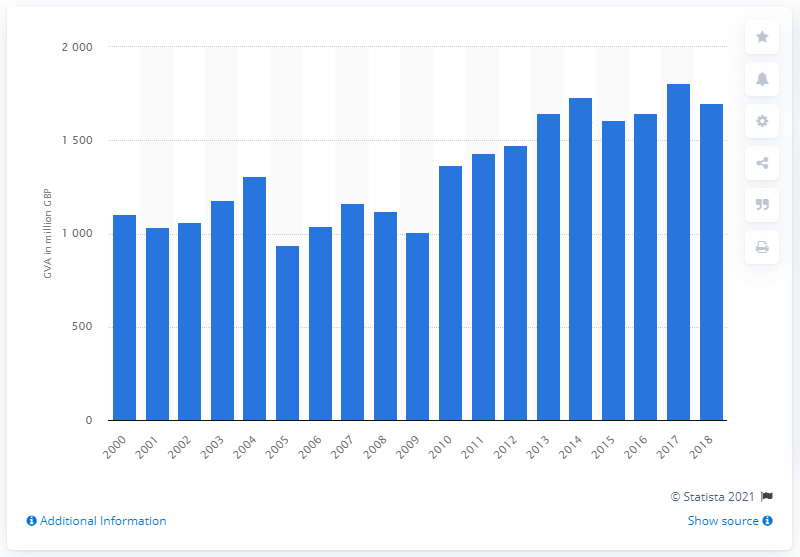Give some essential details in this illustration. In 2017, the Gross Value Added (GVA) of Scotland's agriculture, fishing, and forestry industry reached its peak. In 2017, the Gross Value Added (GVA) of Scotland's agriculture, fishing, and forestry industry was £18.05 billion. 